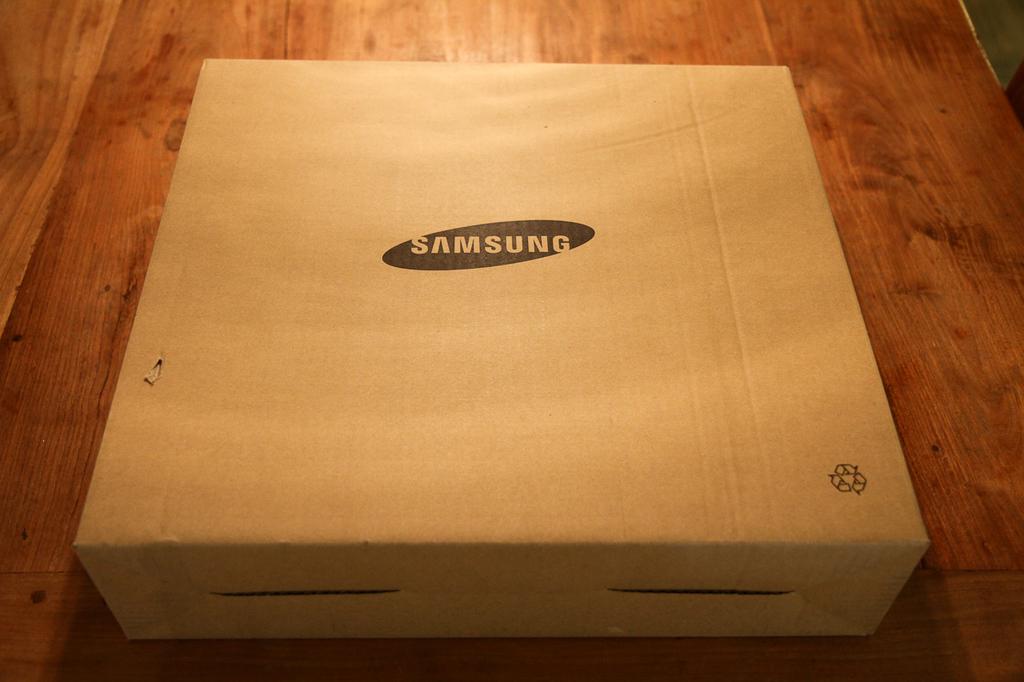What brand is in the box?
Your answer should be very brief. Samsung. 